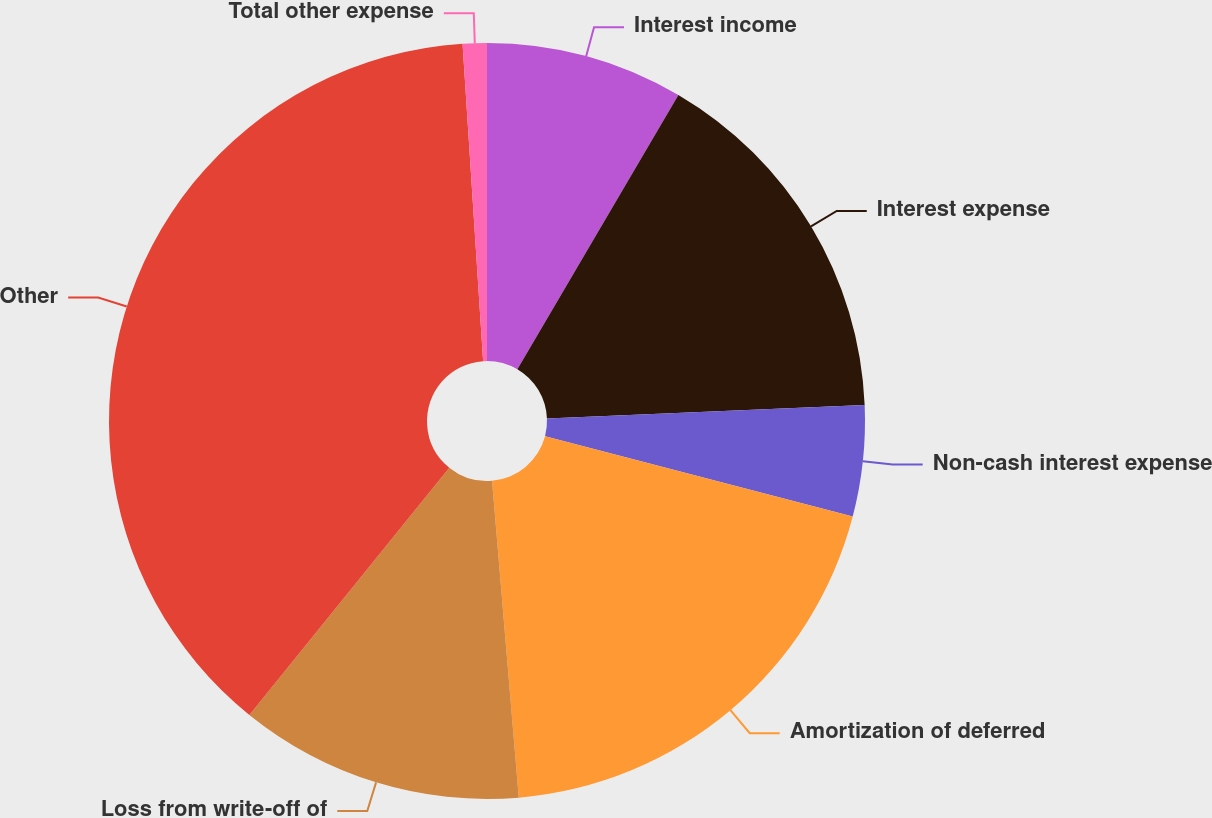Convert chart to OTSL. <chart><loc_0><loc_0><loc_500><loc_500><pie_chart><fcel>Interest income<fcel>Interest expense<fcel>Non-cash interest expense<fcel>Amortization of deferred<fcel>Loss from write-off of<fcel>Other<fcel>Total other expense<nl><fcel>8.45%<fcel>15.88%<fcel>4.74%<fcel>19.59%<fcel>12.16%<fcel>38.15%<fcel>1.03%<nl></chart> 